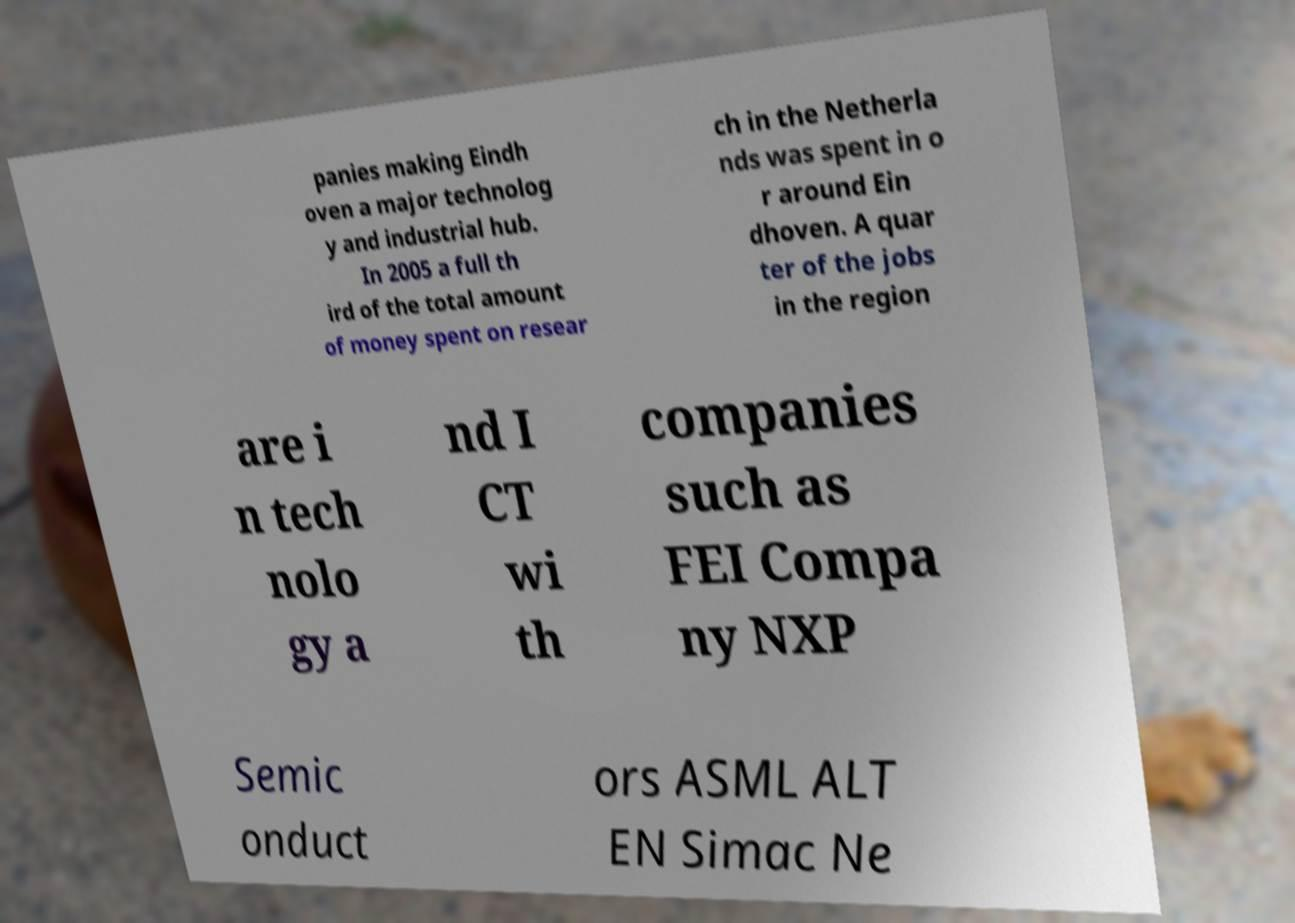Could you extract and type out the text from this image? panies making Eindh oven a major technolog y and industrial hub. In 2005 a full th ird of the total amount of money spent on resear ch in the Netherla nds was spent in o r around Ein dhoven. A quar ter of the jobs in the region are i n tech nolo gy a nd I CT wi th companies such as FEI Compa ny NXP Semic onduct ors ASML ALT EN Simac Ne 